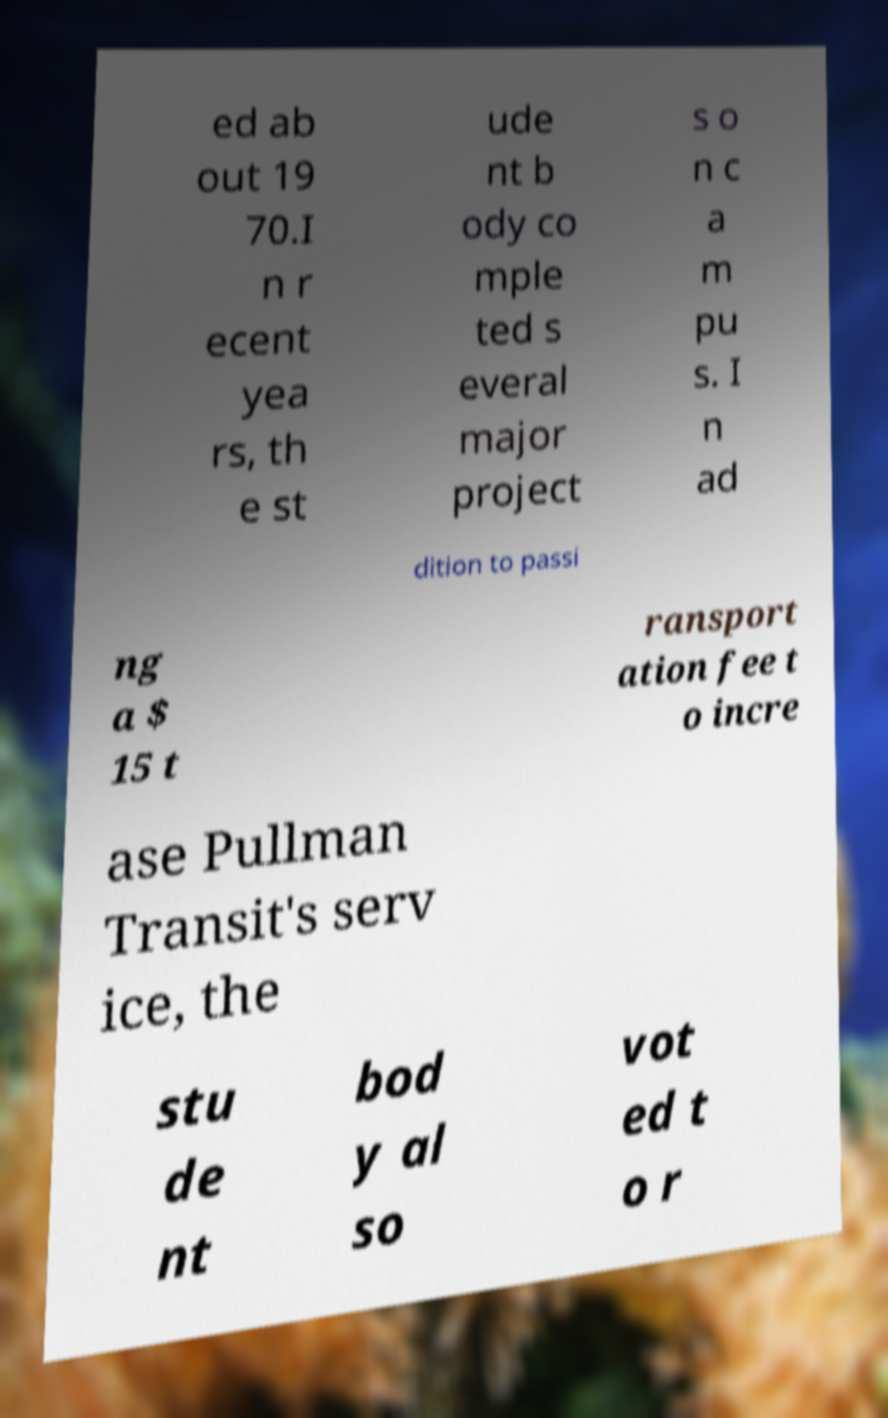For documentation purposes, I need the text within this image transcribed. Could you provide that? ed ab out 19 70.I n r ecent yea rs, th e st ude nt b ody co mple ted s everal major project s o n c a m pu s. I n ad dition to passi ng a $ 15 t ransport ation fee t o incre ase Pullman Transit's serv ice, the stu de nt bod y al so vot ed t o r 